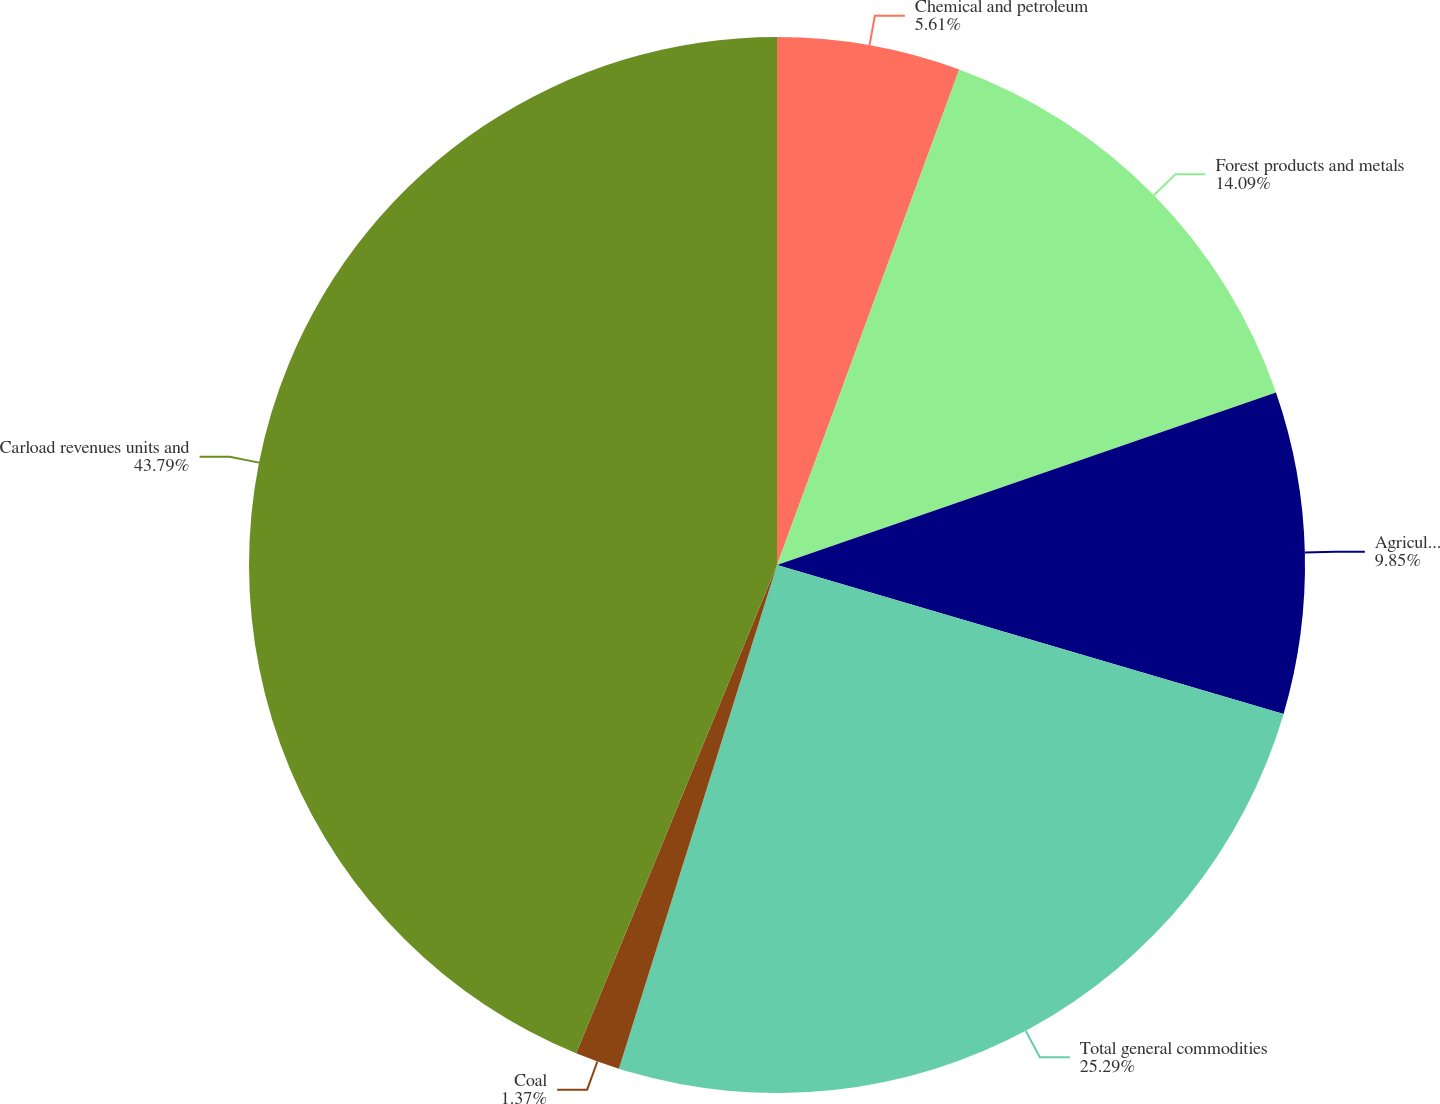Convert chart to OTSL. <chart><loc_0><loc_0><loc_500><loc_500><pie_chart><fcel>Chemical and petroleum<fcel>Forest products and metals<fcel>Agriculture and minerals<fcel>Total general commodities<fcel>Coal<fcel>Carload revenues units and<nl><fcel>5.61%<fcel>14.09%<fcel>9.85%<fcel>25.29%<fcel>1.37%<fcel>43.79%<nl></chart> 